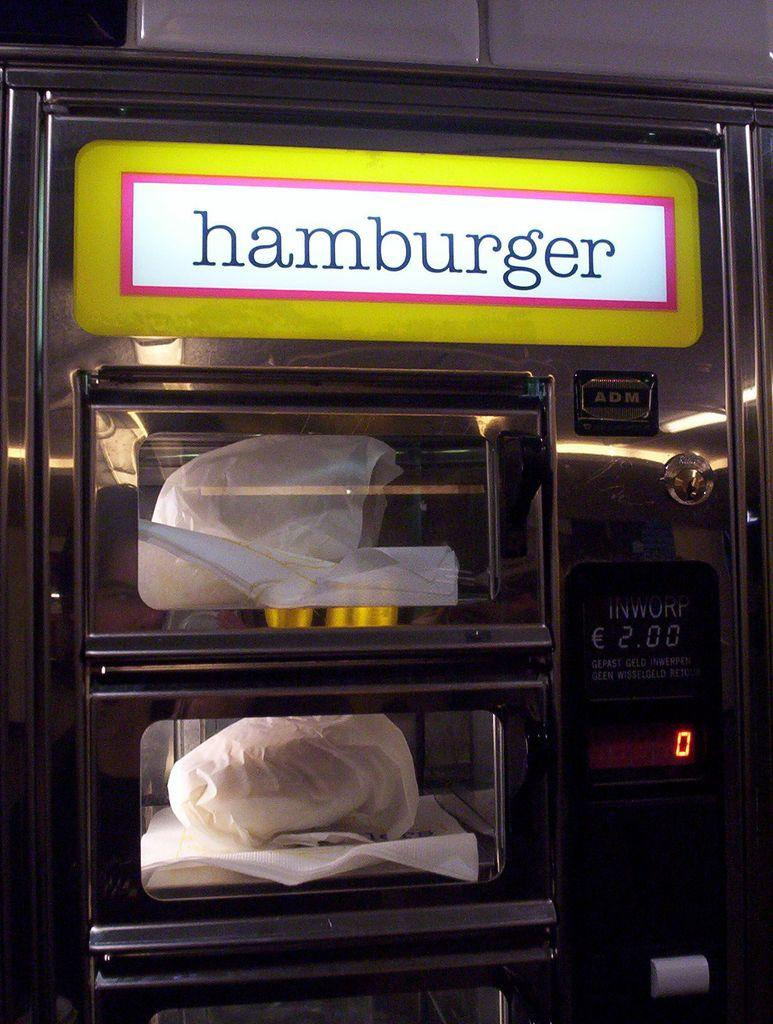<image>
Provide a brief description of the given image. A Hamburger oven that is currently in use. 